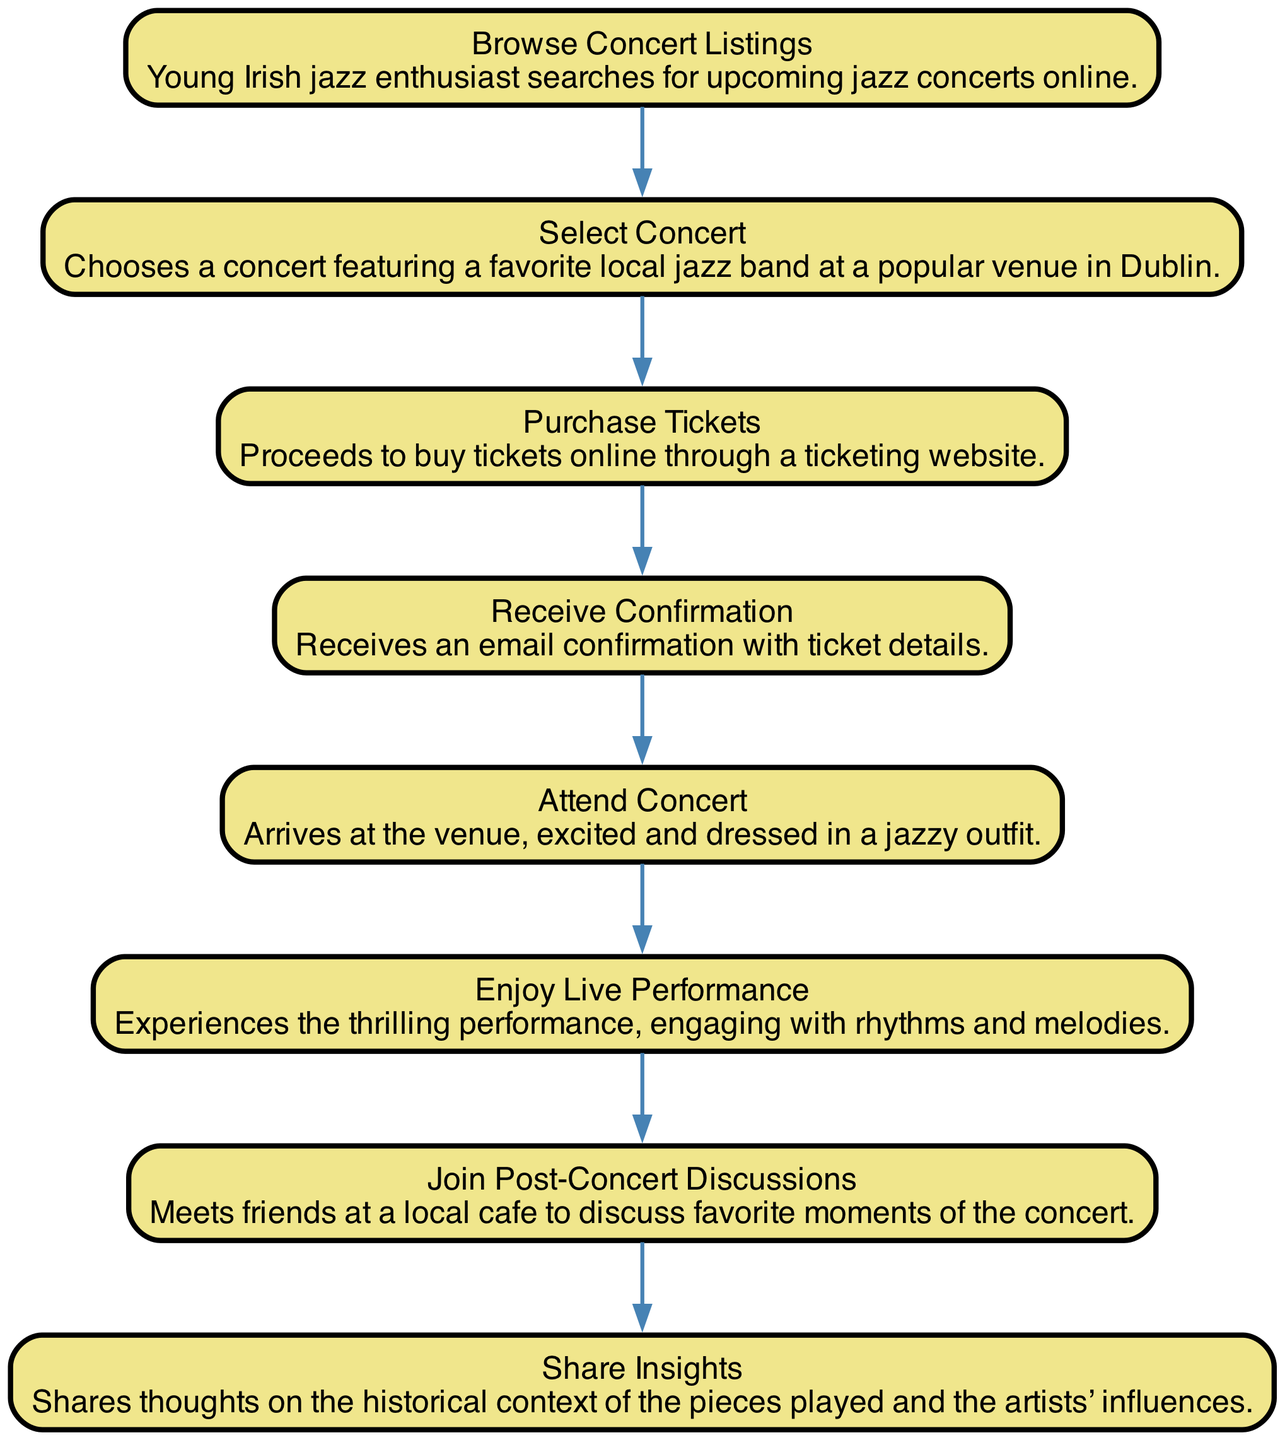What is the first step in the sequence? The first step listed in the diagram is "Browse Concert Listings," where the young Irish jazz enthusiast searches for upcoming jazz concerts online.
Answer: Browse Concert Listings How many steps are there in total? The diagram outlines a total of eight steps from browsing listings to sharing insights, providing a complete view of the concert experience.
Answer: Eight What action follows purchasing tickets? After "Purchase Tickets," the next step is "Receive Confirmation," which involves getting an email confirmation with ticket details.
Answer: Receive Confirmation Which step includes meeting friends? The step that involves meeting friends is "Join Post-Concert Discussions," where the enthusiast discusses favorite moments of the concert with friends.
Answer: Join Post-Concert Discussions What is the relationship between "Enjoy Live Performance" and "Attend Concert"? "Attend Concert" precedes "Enjoy Live Performance"; one must first arrive at the venue before they can experience the performance.
Answer: Attend Concert -> Enjoy Live Performance What is the last step in the sequence? The last step listed in the sequence is "Share Insights," where the young jazz enthusiast shares thoughts on the historical context and influences of the pieces played.
Answer: Share Insights Which step involves excitement about the event? The step that involves excitement is "Attend Concert," where the young Irish jazz enthusiast arrives at the venue excited and dressed in a jazzy outfit.
Answer: Attend Concert What occurs after Enjoy Live Performance? After "Enjoy Live Performance," the next step is "Join Post-Concert Discussions," indicating a transition from experiencing to discussing the event.
Answer: Join Post-Concert Discussions 